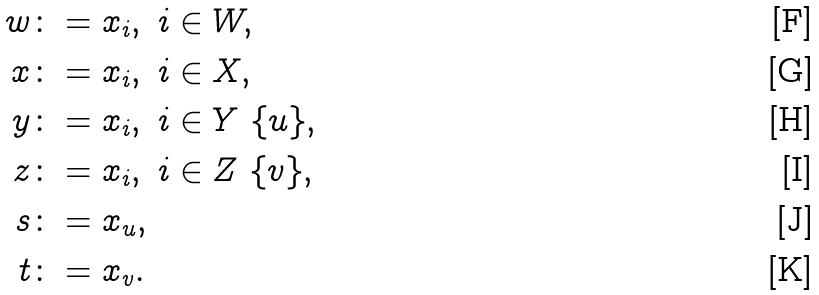<formula> <loc_0><loc_0><loc_500><loc_500>w & \colon = x _ { i } , \ i \in W , \\ x & \colon = x _ { i } , \ i \in X , \\ y & \colon = x _ { i } , \ i \in Y \ \{ u \} , \\ z & \colon = x _ { i } , \ i \in Z \ \{ v \} , \\ s & \colon = x _ { u } , \\ t & \colon = x _ { v } .</formula> 